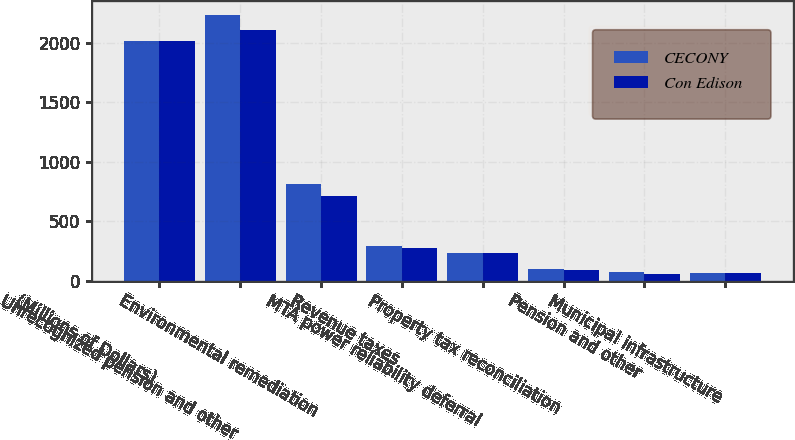Convert chart. <chart><loc_0><loc_0><loc_500><loc_500><stacked_bar_chart><ecel><fcel>(Millions of Dollars)<fcel>Unrecognized pension and other<fcel>Environmental remediation<fcel>Revenue taxes<fcel>MTA power reliability deferral<fcel>Property tax reconciliation<fcel>Pension and other<fcel>Municipal infrastructure<nl><fcel>CECONY<fcel>2018<fcel>2238<fcel>810<fcel>291<fcel>229<fcel>101<fcel>73<fcel>67<nl><fcel>Con Edison<fcel>2018<fcel>2111<fcel>716<fcel>278<fcel>229<fcel>86<fcel>56<fcel>67<nl></chart> 